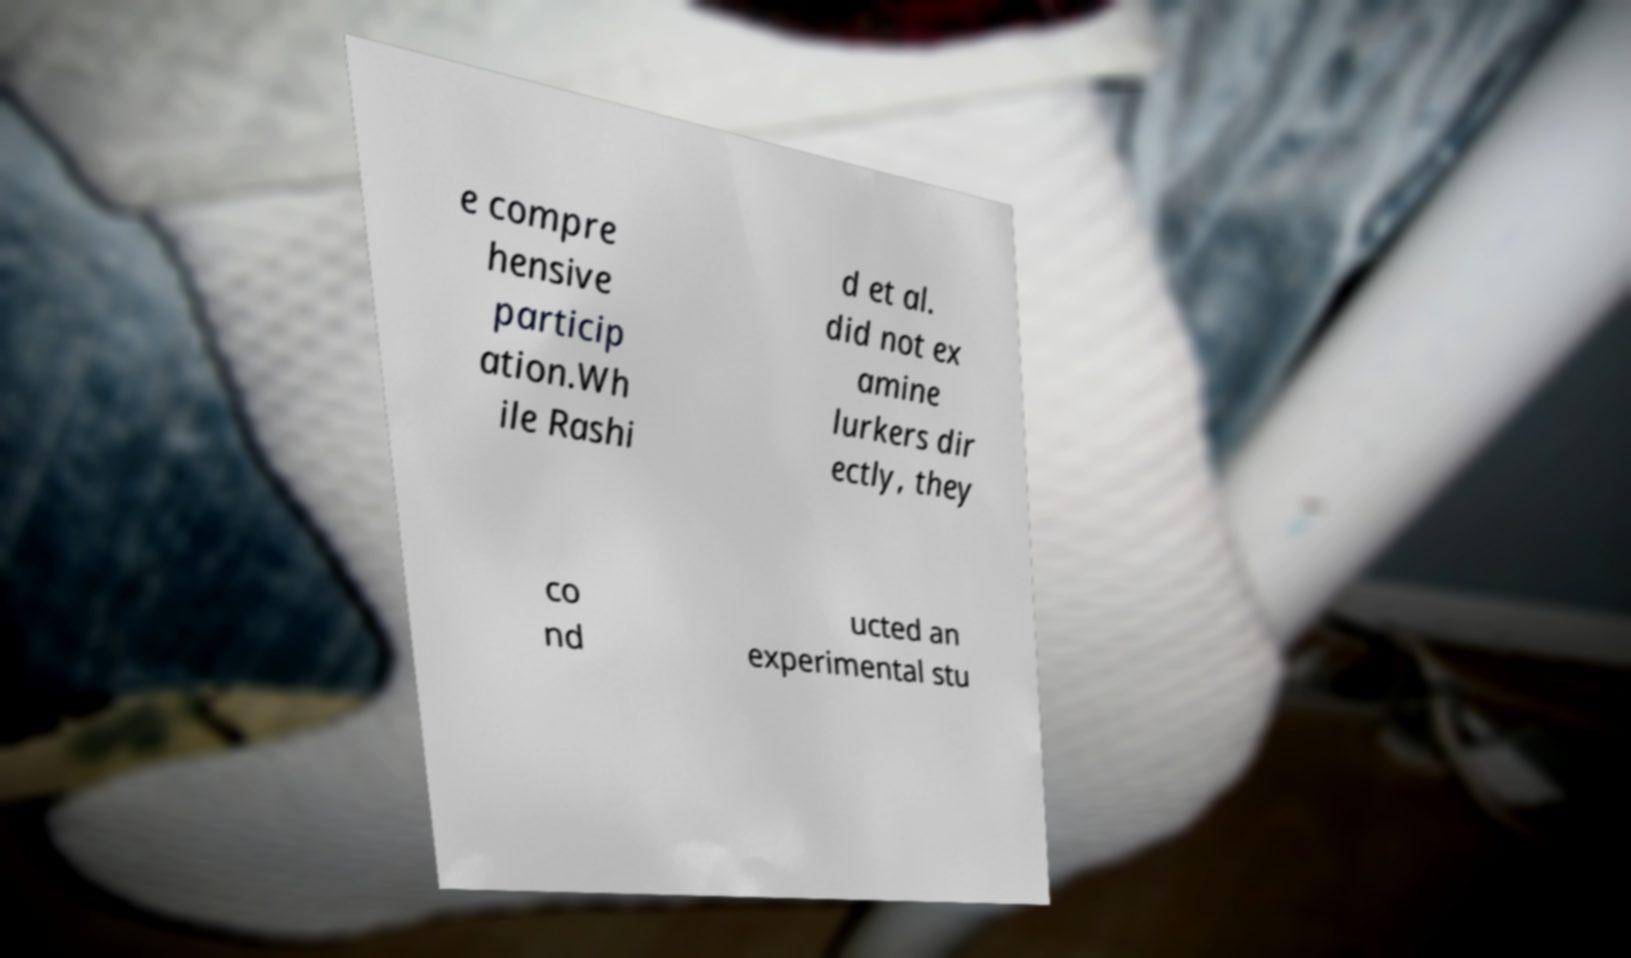For documentation purposes, I need the text within this image transcribed. Could you provide that? e compre hensive particip ation.Wh ile Rashi d et al. did not ex amine lurkers dir ectly, they co nd ucted an experimental stu 